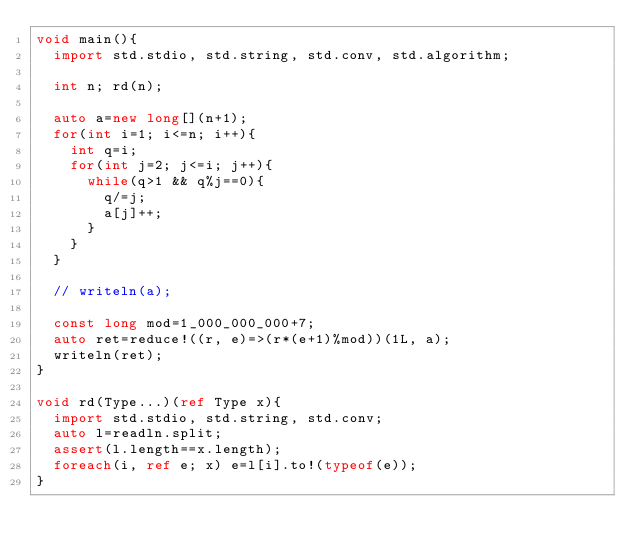Convert code to text. <code><loc_0><loc_0><loc_500><loc_500><_D_>void main(){
  import std.stdio, std.string, std.conv, std.algorithm;

  int n; rd(n);

  auto a=new long[](n+1);
  for(int i=1; i<=n; i++){
    int q=i;
    for(int j=2; j<=i; j++){
      while(q>1 && q%j==0){
        q/=j;
        a[j]++;
      }
    }
  }

  // writeln(a);

  const long mod=1_000_000_000+7;
  auto ret=reduce!((r, e)=>(r*(e+1)%mod))(1L, a);
  writeln(ret);
}

void rd(Type...)(ref Type x){
  import std.stdio, std.string, std.conv;
  auto l=readln.split;
  assert(l.length==x.length);
  foreach(i, ref e; x) e=l[i].to!(typeof(e));
}</code> 